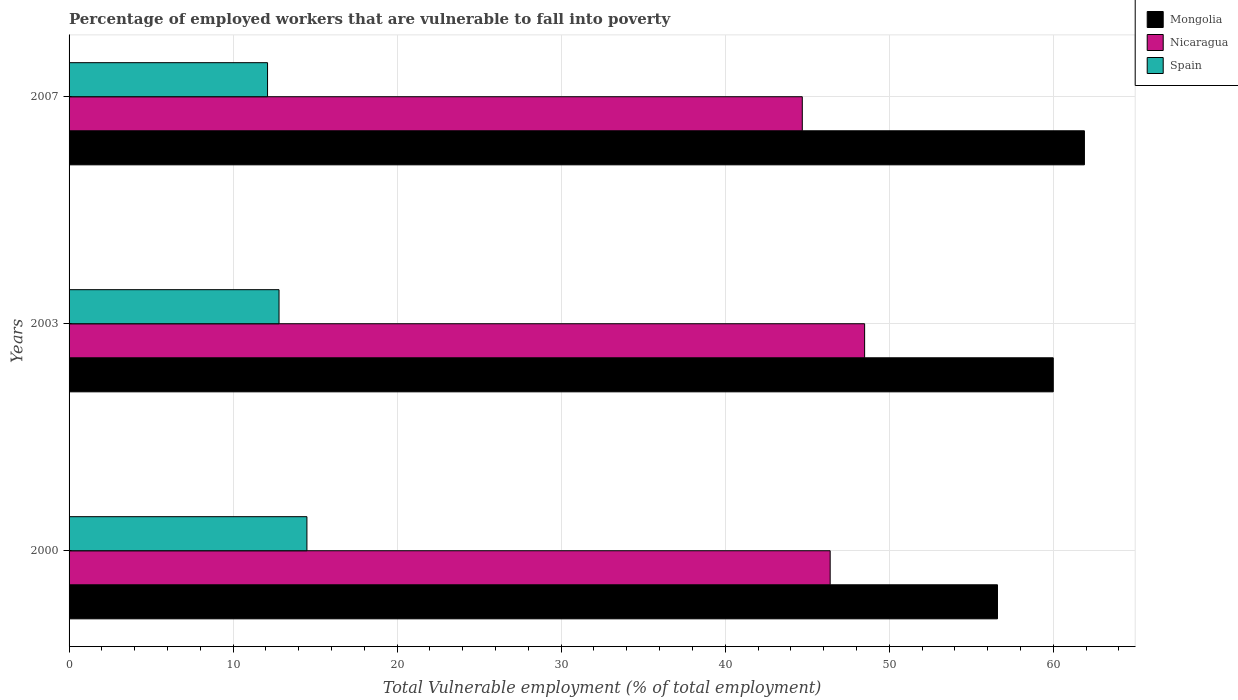How many different coloured bars are there?
Provide a succinct answer. 3. How many groups of bars are there?
Offer a very short reply. 3. Are the number of bars on each tick of the Y-axis equal?
Your response must be concise. Yes. In how many cases, is the number of bars for a given year not equal to the number of legend labels?
Offer a terse response. 0. What is the percentage of employed workers who are vulnerable to fall into poverty in Nicaragua in 2007?
Give a very brief answer. 44.7. Across all years, what is the minimum percentage of employed workers who are vulnerable to fall into poverty in Nicaragua?
Provide a short and direct response. 44.7. In which year was the percentage of employed workers who are vulnerable to fall into poverty in Mongolia minimum?
Your answer should be very brief. 2000. What is the total percentage of employed workers who are vulnerable to fall into poverty in Spain in the graph?
Your response must be concise. 39.4. What is the difference between the percentage of employed workers who are vulnerable to fall into poverty in Mongolia in 2000 and that in 2007?
Provide a succinct answer. -5.3. What is the difference between the percentage of employed workers who are vulnerable to fall into poverty in Mongolia in 2000 and the percentage of employed workers who are vulnerable to fall into poverty in Spain in 2007?
Offer a very short reply. 44.5. What is the average percentage of employed workers who are vulnerable to fall into poverty in Nicaragua per year?
Ensure brevity in your answer.  46.53. In the year 2007, what is the difference between the percentage of employed workers who are vulnerable to fall into poverty in Spain and percentage of employed workers who are vulnerable to fall into poverty in Nicaragua?
Provide a succinct answer. -32.6. What is the ratio of the percentage of employed workers who are vulnerable to fall into poverty in Nicaragua in 2003 to that in 2007?
Provide a succinct answer. 1.09. What is the difference between the highest and the second highest percentage of employed workers who are vulnerable to fall into poverty in Spain?
Make the answer very short. 1.7. What is the difference between the highest and the lowest percentage of employed workers who are vulnerable to fall into poverty in Mongolia?
Provide a succinct answer. 5.3. Is the sum of the percentage of employed workers who are vulnerable to fall into poverty in Mongolia in 2003 and 2007 greater than the maximum percentage of employed workers who are vulnerable to fall into poverty in Nicaragua across all years?
Your answer should be very brief. Yes. What does the 2nd bar from the top in 2000 represents?
Provide a short and direct response. Nicaragua. How many years are there in the graph?
Your response must be concise. 3. Are the values on the major ticks of X-axis written in scientific E-notation?
Your answer should be very brief. No. Does the graph contain any zero values?
Offer a very short reply. No. Does the graph contain grids?
Make the answer very short. Yes. Where does the legend appear in the graph?
Offer a terse response. Top right. How many legend labels are there?
Make the answer very short. 3. What is the title of the graph?
Your answer should be compact. Percentage of employed workers that are vulnerable to fall into poverty. What is the label or title of the X-axis?
Your answer should be very brief. Total Vulnerable employment (% of total employment). What is the Total Vulnerable employment (% of total employment) of Mongolia in 2000?
Provide a short and direct response. 56.6. What is the Total Vulnerable employment (% of total employment) of Nicaragua in 2000?
Keep it short and to the point. 46.4. What is the Total Vulnerable employment (% of total employment) in Spain in 2000?
Offer a terse response. 14.5. What is the Total Vulnerable employment (% of total employment) of Mongolia in 2003?
Ensure brevity in your answer.  60. What is the Total Vulnerable employment (% of total employment) in Nicaragua in 2003?
Provide a short and direct response. 48.5. What is the Total Vulnerable employment (% of total employment) of Spain in 2003?
Keep it short and to the point. 12.8. What is the Total Vulnerable employment (% of total employment) in Mongolia in 2007?
Make the answer very short. 61.9. What is the Total Vulnerable employment (% of total employment) in Nicaragua in 2007?
Ensure brevity in your answer.  44.7. What is the Total Vulnerable employment (% of total employment) in Spain in 2007?
Your answer should be compact. 12.1. Across all years, what is the maximum Total Vulnerable employment (% of total employment) of Mongolia?
Keep it short and to the point. 61.9. Across all years, what is the maximum Total Vulnerable employment (% of total employment) of Nicaragua?
Keep it short and to the point. 48.5. Across all years, what is the maximum Total Vulnerable employment (% of total employment) in Spain?
Offer a terse response. 14.5. Across all years, what is the minimum Total Vulnerable employment (% of total employment) in Mongolia?
Ensure brevity in your answer.  56.6. Across all years, what is the minimum Total Vulnerable employment (% of total employment) of Nicaragua?
Offer a terse response. 44.7. Across all years, what is the minimum Total Vulnerable employment (% of total employment) of Spain?
Your answer should be compact. 12.1. What is the total Total Vulnerable employment (% of total employment) in Mongolia in the graph?
Make the answer very short. 178.5. What is the total Total Vulnerable employment (% of total employment) of Nicaragua in the graph?
Your response must be concise. 139.6. What is the total Total Vulnerable employment (% of total employment) in Spain in the graph?
Give a very brief answer. 39.4. What is the difference between the Total Vulnerable employment (% of total employment) in Mongolia in 2000 and that in 2003?
Offer a very short reply. -3.4. What is the difference between the Total Vulnerable employment (% of total employment) in Nicaragua in 2000 and that in 2003?
Offer a terse response. -2.1. What is the difference between the Total Vulnerable employment (% of total employment) of Spain in 2000 and that in 2003?
Provide a short and direct response. 1.7. What is the difference between the Total Vulnerable employment (% of total employment) in Mongolia in 2000 and that in 2007?
Provide a short and direct response. -5.3. What is the difference between the Total Vulnerable employment (% of total employment) in Nicaragua in 2000 and that in 2007?
Your answer should be compact. 1.7. What is the difference between the Total Vulnerable employment (% of total employment) of Spain in 2000 and that in 2007?
Ensure brevity in your answer.  2.4. What is the difference between the Total Vulnerable employment (% of total employment) in Mongolia in 2003 and that in 2007?
Offer a very short reply. -1.9. What is the difference between the Total Vulnerable employment (% of total employment) in Spain in 2003 and that in 2007?
Provide a succinct answer. 0.7. What is the difference between the Total Vulnerable employment (% of total employment) of Mongolia in 2000 and the Total Vulnerable employment (% of total employment) of Spain in 2003?
Your response must be concise. 43.8. What is the difference between the Total Vulnerable employment (% of total employment) in Nicaragua in 2000 and the Total Vulnerable employment (% of total employment) in Spain in 2003?
Your answer should be compact. 33.6. What is the difference between the Total Vulnerable employment (% of total employment) of Mongolia in 2000 and the Total Vulnerable employment (% of total employment) of Spain in 2007?
Offer a very short reply. 44.5. What is the difference between the Total Vulnerable employment (% of total employment) in Nicaragua in 2000 and the Total Vulnerable employment (% of total employment) in Spain in 2007?
Give a very brief answer. 34.3. What is the difference between the Total Vulnerable employment (% of total employment) of Mongolia in 2003 and the Total Vulnerable employment (% of total employment) of Nicaragua in 2007?
Make the answer very short. 15.3. What is the difference between the Total Vulnerable employment (% of total employment) of Mongolia in 2003 and the Total Vulnerable employment (% of total employment) of Spain in 2007?
Offer a terse response. 47.9. What is the difference between the Total Vulnerable employment (% of total employment) of Nicaragua in 2003 and the Total Vulnerable employment (% of total employment) of Spain in 2007?
Make the answer very short. 36.4. What is the average Total Vulnerable employment (% of total employment) of Mongolia per year?
Provide a short and direct response. 59.5. What is the average Total Vulnerable employment (% of total employment) of Nicaragua per year?
Give a very brief answer. 46.53. What is the average Total Vulnerable employment (% of total employment) of Spain per year?
Offer a terse response. 13.13. In the year 2000, what is the difference between the Total Vulnerable employment (% of total employment) in Mongolia and Total Vulnerable employment (% of total employment) in Spain?
Keep it short and to the point. 42.1. In the year 2000, what is the difference between the Total Vulnerable employment (% of total employment) of Nicaragua and Total Vulnerable employment (% of total employment) of Spain?
Your response must be concise. 31.9. In the year 2003, what is the difference between the Total Vulnerable employment (% of total employment) in Mongolia and Total Vulnerable employment (% of total employment) in Nicaragua?
Your response must be concise. 11.5. In the year 2003, what is the difference between the Total Vulnerable employment (% of total employment) of Mongolia and Total Vulnerable employment (% of total employment) of Spain?
Provide a short and direct response. 47.2. In the year 2003, what is the difference between the Total Vulnerable employment (% of total employment) in Nicaragua and Total Vulnerable employment (% of total employment) in Spain?
Your response must be concise. 35.7. In the year 2007, what is the difference between the Total Vulnerable employment (% of total employment) of Mongolia and Total Vulnerable employment (% of total employment) of Spain?
Your response must be concise. 49.8. In the year 2007, what is the difference between the Total Vulnerable employment (% of total employment) in Nicaragua and Total Vulnerable employment (% of total employment) in Spain?
Make the answer very short. 32.6. What is the ratio of the Total Vulnerable employment (% of total employment) in Mongolia in 2000 to that in 2003?
Provide a short and direct response. 0.94. What is the ratio of the Total Vulnerable employment (% of total employment) of Nicaragua in 2000 to that in 2003?
Your answer should be compact. 0.96. What is the ratio of the Total Vulnerable employment (% of total employment) in Spain in 2000 to that in 2003?
Keep it short and to the point. 1.13. What is the ratio of the Total Vulnerable employment (% of total employment) of Mongolia in 2000 to that in 2007?
Provide a short and direct response. 0.91. What is the ratio of the Total Vulnerable employment (% of total employment) in Nicaragua in 2000 to that in 2007?
Provide a short and direct response. 1.04. What is the ratio of the Total Vulnerable employment (% of total employment) of Spain in 2000 to that in 2007?
Keep it short and to the point. 1.2. What is the ratio of the Total Vulnerable employment (% of total employment) in Mongolia in 2003 to that in 2007?
Ensure brevity in your answer.  0.97. What is the ratio of the Total Vulnerable employment (% of total employment) in Nicaragua in 2003 to that in 2007?
Your answer should be compact. 1.08. What is the ratio of the Total Vulnerable employment (% of total employment) in Spain in 2003 to that in 2007?
Your response must be concise. 1.06. What is the difference between the highest and the second highest Total Vulnerable employment (% of total employment) in Spain?
Your answer should be very brief. 1.7. What is the difference between the highest and the lowest Total Vulnerable employment (% of total employment) in Nicaragua?
Your answer should be compact. 3.8. 